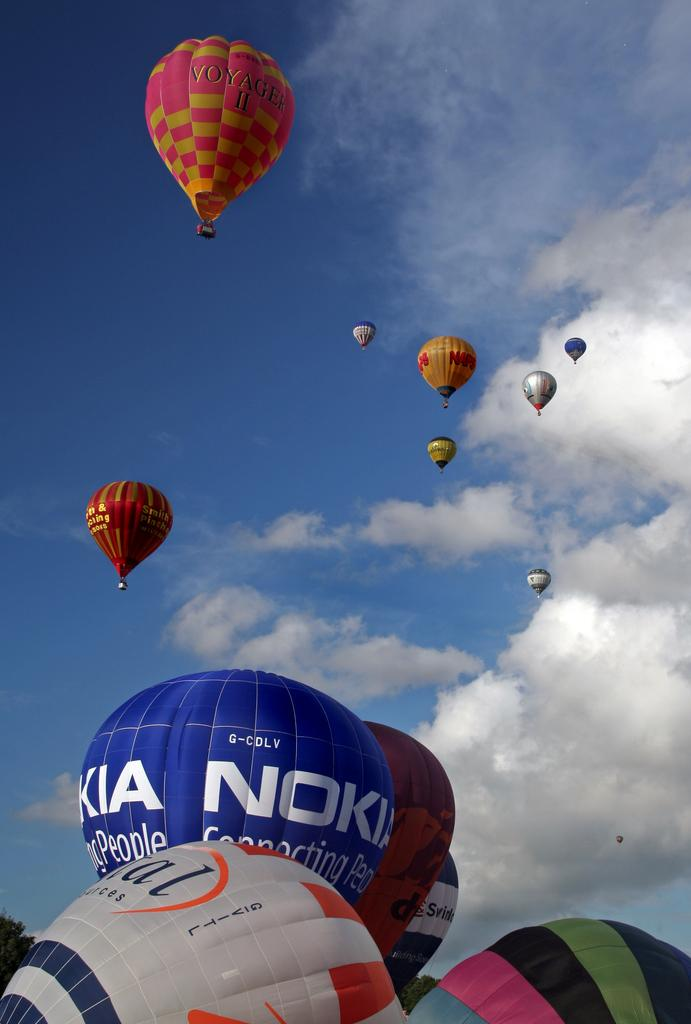<image>
Relay a brief, clear account of the picture shown. colorful hot air balloons include ones by Voyager II and Nokia 